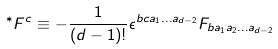<formula> <loc_0><loc_0><loc_500><loc_500>^ { * } F ^ { c } \equiv - \frac { 1 } { ( d - 1 ) ! } \epsilon ^ { b c a _ { 1 } \dots a _ { d - 2 } } F _ { b a _ { 1 } a _ { 2 } \dots a _ { d - 2 } }</formula> 